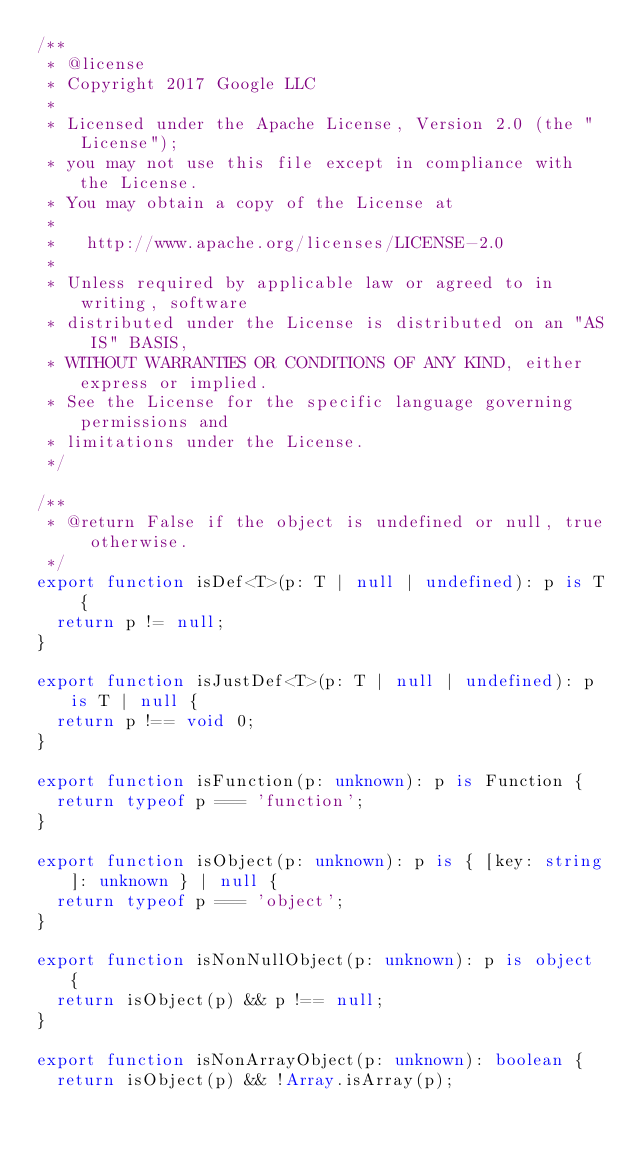Convert code to text. <code><loc_0><loc_0><loc_500><loc_500><_TypeScript_>/**
 * @license
 * Copyright 2017 Google LLC
 *
 * Licensed under the Apache License, Version 2.0 (the "License");
 * you may not use this file except in compliance with the License.
 * You may obtain a copy of the License at
 *
 *   http://www.apache.org/licenses/LICENSE-2.0
 *
 * Unless required by applicable law or agreed to in writing, software
 * distributed under the License is distributed on an "AS IS" BASIS,
 * WITHOUT WARRANTIES OR CONDITIONS OF ANY KIND, either express or implied.
 * See the License for the specific language governing permissions and
 * limitations under the License.
 */

/**
 * @return False if the object is undefined or null, true otherwise.
 */
export function isDef<T>(p: T | null | undefined): p is T {
  return p != null;
}

export function isJustDef<T>(p: T | null | undefined): p is T | null {
  return p !== void 0;
}

export function isFunction(p: unknown): p is Function {
  return typeof p === 'function';
}

export function isObject(p: unknown): p is { [key: string]: unknown } | null {
  return typeof p === 'object';
}

export function isNonNullObject(p: unknown): p is object {
  return isObject(p) && p !== null;
}

export function isNonArrayObject(p: unknown): boolean {
  return isObject(p) && !Array.isArray(p);</code> 